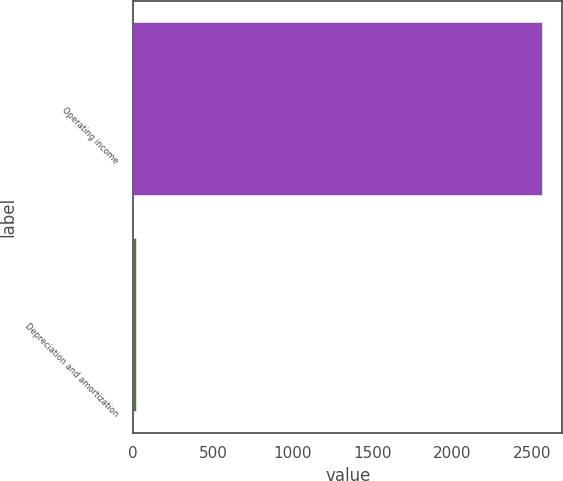Convert chart to OTSL. <chart><loc_0><loc_0><loc_500><loc_500><bar_chart><fcel>Operating income<fcel>Depreciation and amortization<nl><fcel>2563.9<fcel>15<nl></chart> 